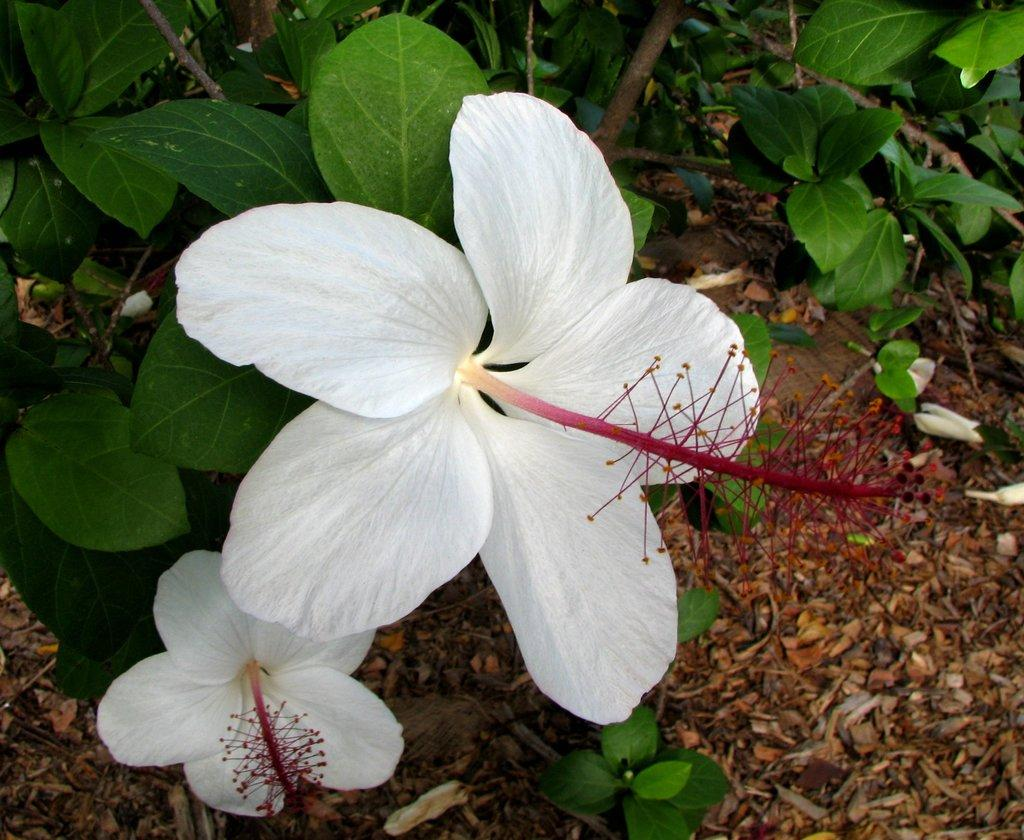What type of flowers can be seen in the image? There are white color flowers in the image. What else can be seen in the background of the image? There are leaves in the background of the image. What type of ice can be seen melting on the flowers in the image? There is no ice present in the image; it features white color flowers and leaves in the background. 